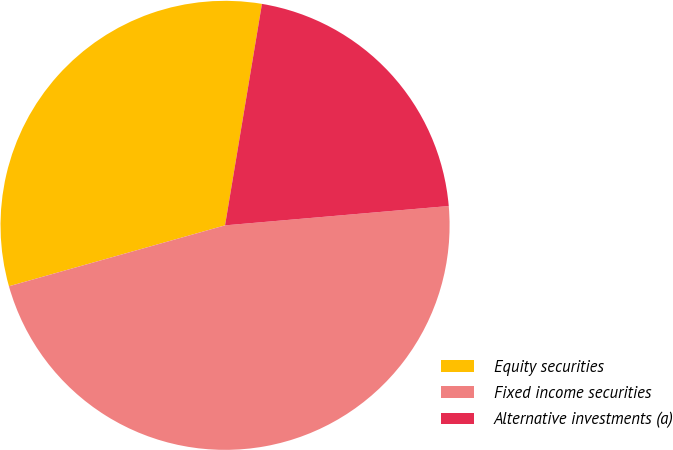<chart> <loc_0><loc_0><loc_500><loc_500><pie_chart><fcel>Equity securities<fcel>Fixed income securities<fcel>Alternative investments (a)<nl><fcel>32.0%<fcel>47.0%<fcel>21.0%<nl></chart> 